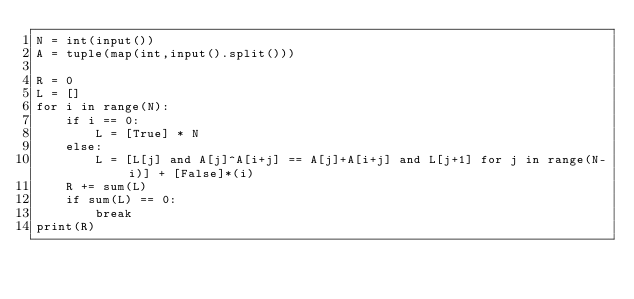Convert code to text. <code><loc_0><loc_0><loc_500><loc_500><_Python_>N = int(input())
A = tuple(map(int,input().split()))

R = 0
L = []
for i in range(N):
    if i == 0:
        L = [True] * N
    else:
        L = [L[j] and A[j]^A[i+j] == A[j]+A[i+j] and L[j+1] for j in range(N-i)] + [False]*(i) 
    R += sum(L)
    if sum(L) == 0:
        break
print(R)</code> 